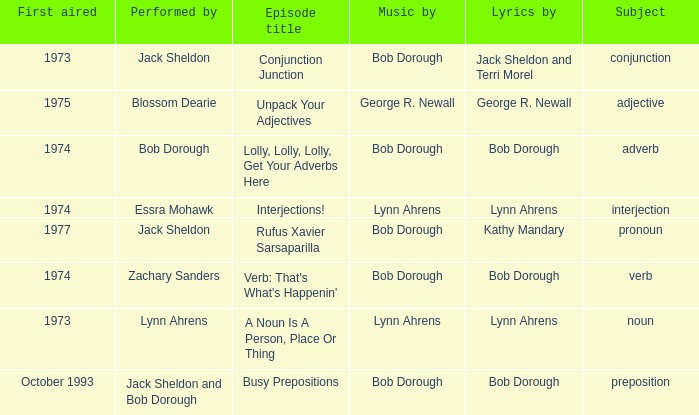When the performer is zachary sanders, what is the number of people involved in creating the music? 1.0. 